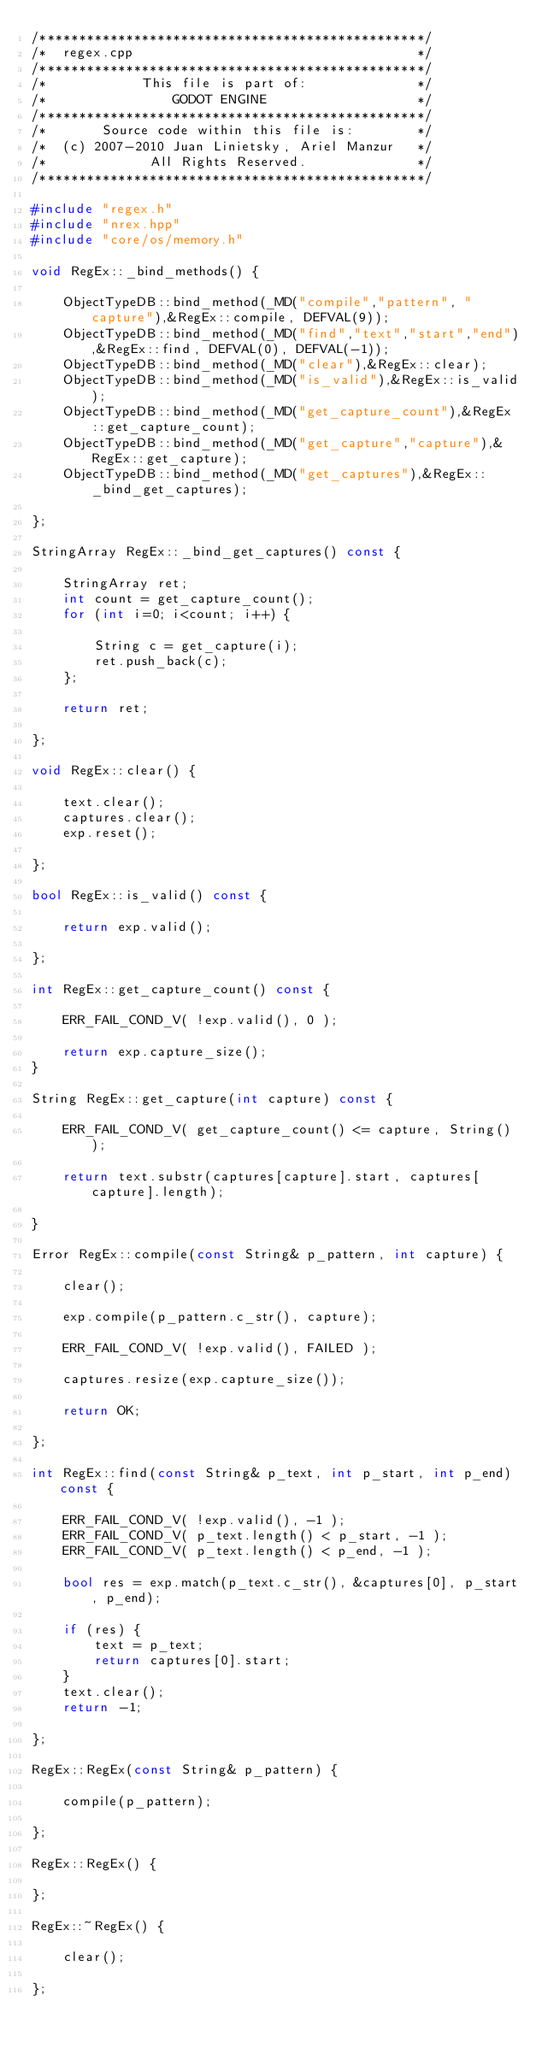<code> <loc_0><loc_0><loc_500><loc_500><_C++_>/*************************************************/
/*  regex.cpp                                    */
/*************************************************/
/*            This file is part of:              */
/*                GODOT ENGINE                   */
/*************************************************/
/*       Source code within this file is:        */
/*  (c) 2007-2010 Juan Linietsky, Ariel Manzur   */
/*             All Rights Reserved.              */
/*************************************************/

#include "regex.h"
#include "nrex.hpp"
#include "core/os/memory.h"

void RegEx::_bind_methods() {

	ObjectTypeDB::bind_method(_MD("compile","pattern", "capture"),&RegEx::compile, DEFVAL(9));
	ObjectTypeDB::bind_method(_MD("find","text","start","end"),&RegEx::find, DEFVAL(0), DEFVAL(-1));
	ObjectTypeDB::bind_method(_MD("clear"),&RegEx::clear);
	ObjectTypeDB::bind_method(_MD("is_valid"),&RegEx::is_valid);
	ObjectTypeDB::bind_method(_MD("get_capture_count"),&RegEx::get_capture_count);
	ObjectTypeDB::bind_method(_MD("get_capture","capture"),&RegEx::get_capture);
	ObjectTypeDB::bind_method(_MD("get_captures"),&RegEx::_bind_get_captures);

};

StringArray RegEx::_bind_get_captures() const {

	StringArray ret;
	int count = get_capture_count();
	for (int i=0; i<count; i++) {

		String c = get_capture(i);
		ret.push_back(c);
	};

	return ret;

};

void RegEx::clear() {

	text.clear();
	captures.clear();
	exp.reset();

};

bool RegEx::is_valid() const {

	return exp.valid();

};

int RegEx::get_capture_count() const {

	ERR_FAIL_COND_V( !exp.valid(), 0 );

	return exp.capture_size();
}

String RegEx::get_capture(int capture) const {

	ERR_FAIL_COND_V( get_capture_count() <= capture, String() );

	return text.substr(captures[capture].start, captures[capture].length);

}

Error RegEx::compile(const String& p_pattern, int capture) {

	clear();

	exp.compile(p_pattern.c_str(), capture);

	ERR_FAIL_COND_V( !exp.valid(), FAILED );

	captures.resize(exp.capture_size());

	return OK;

};

int RegEx::find(const String& p_text, int p_start, int p_end) const {

	ERR_FAIL_COND_V( !exp.valid(), -1 );
	ERR_FAIL_COND_V( p_text.length() < p_start, -1 );
	ERR_FAIL_COND_V( p_text.length() < p_end, -1 );

	bool res = exp.match(p_text.c_str(), &captures[0], p_start, p_end);

	if (res) {
		text = p_text;
		return captures[0].start;
	}
	text.clear();
	return -1;

};

RegEx::RegEx(const String& p_pattern) {

	compile(p_pattern);

};

RegEx::RegEx() {

};

RegEx::~RegEx() {

	clear();

};
</code> 